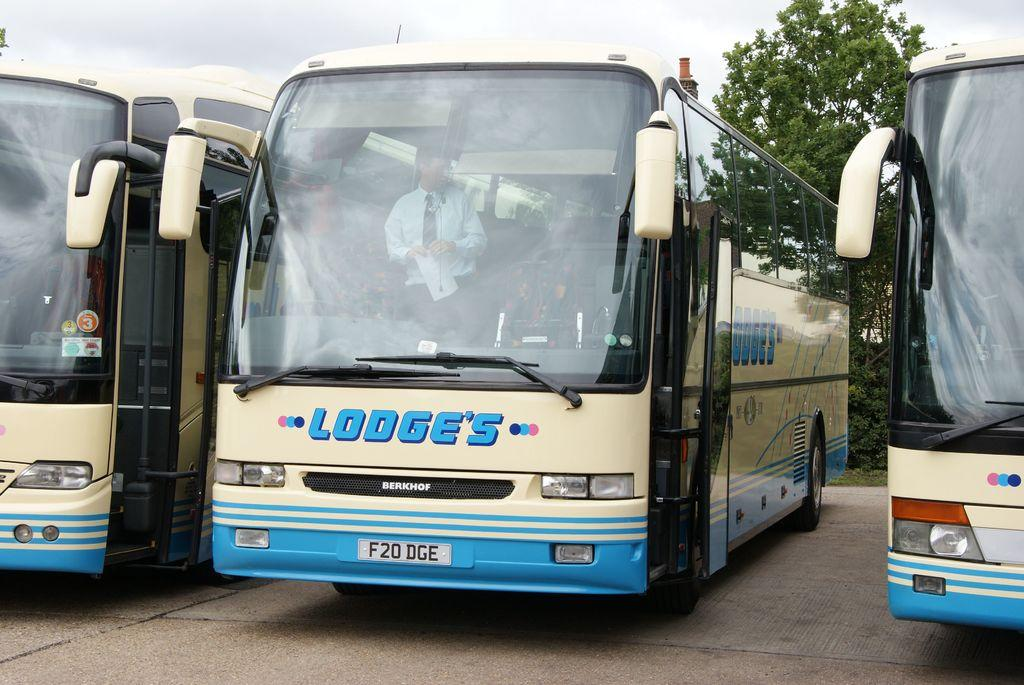What type of vehicles are in the image? There are buses in the image. Can you describe the man inside the bus? The man is standing inside the bus and holding a paper in his hands. What can be seen in the background of the image? There are trees and the sky visible in the background of the image. What is the condition of the sky in the image? Clouds are present in the sky. What type of quill is the man using to write on the paper in the image? There is no quill present in the image; the man is holding a paper but not using a writing instrument. What place is the man acting in the image? The question is unclear, as the man is not performing an action or role in the image. The man is simply standing inside the bus holding a paper. 